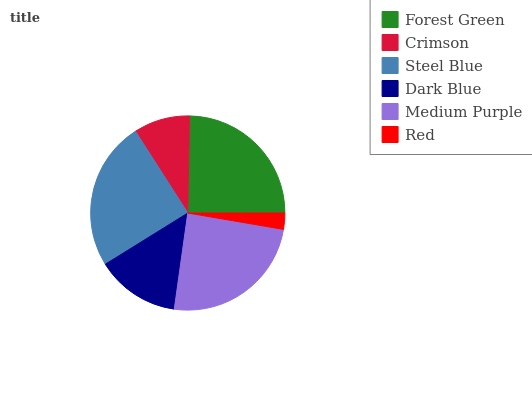Is Red the minimum?
Answer yes or no. Yes. Is Steel Blue the maximum?
Answer yes or no. Yes. Is Crimson the minimum?
Answer yes or no. No. Is Crimson the maximum?
Answer yes or no. No. Is Forest Green greater than Crimson?
Answer yes or no. Yes. Is Crimson less than Forest Green?
Answer yes or no. Yes. Is Crimson greater than Forest Green?
Answer yes or no. No. Is Forest Green less than Crimson?
Answer yes or no. No. Is Medium Purple the high median?
Answer yes or no. Yes. Is Dark Blue the low median?
Answer yes or no. Yes. Is Steel Blue the high median?
Answer yes or no. No. Is Crimson the low median?
Answer yes or no. No. 